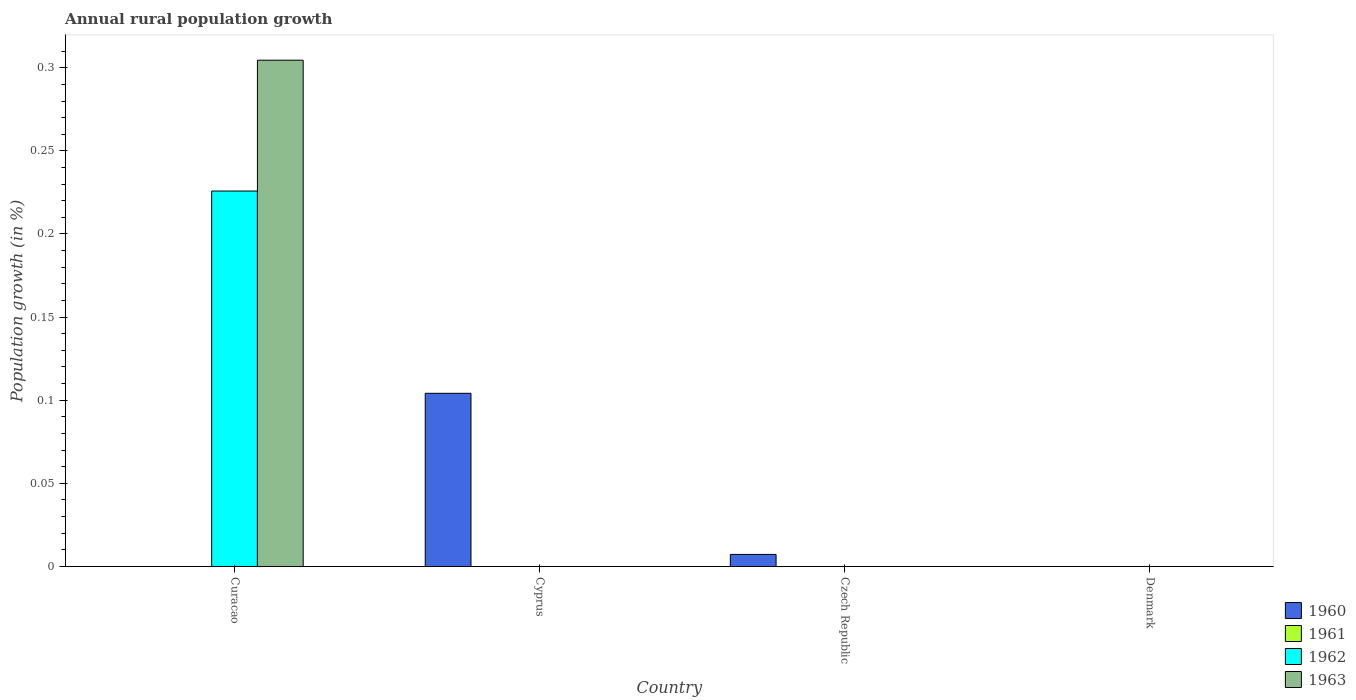How many bars are there on the 4th tick from the left?
Offer a terse response. 0. What is the label of the 4th group of bars from the left?
Your response must be concise. Denmark. Across all countries, what is the maximum percentage of rural population growth in 1962?
Keep it short and to the point. 0.23. Across all countries, what is the minimum percentage of rural population growth in 1962?
Your response must be concise. 0. In which country was the percentage of rural population growth in 1962 maximum?
Your response must be concise. Curacao. What is the total percentage of rural population growth in 1961 in the graph?
Provide a succinct answer. 0. What is the difference between the percentage of rural population growth in 1963 in Curacao and the percentage of rural population growth in 1961 in Cyprus?
Provide a succinct answer. 0.3. In how many countries, is the percentage of rural population growth in 1961 greater than 0.04 %?
Offer a terse response. 0. What is the difference between the highest and the lowest percentage of rural population growth in 1962?
Provide a short and direct response. 0.23. Are all the bars in the graph horizontal?
Your answer should be compact. No. What is the difference between two consecutive major ticks on the Y-axis?
Offer a very short reply. 0.05. Are the values on the major ticks of Y-axis written in scientific E-notation?
Your answer should be compact. No. Does the graph contain grids?
Keep it short and to the point. No. What is the title of the graph?
Ensure brevity in your answer.  Annual rural population growth. What is the label or title of the Y-axis?
Offer a very short reply. Population growth (in %). What is the Population growth (in %) in 1961 in Curacao?
Ensure brevity in your answer.  0. What is the Population growth (in %) in 1962 in Curacao?
Ensure brevity in your answer.  0.23. What is the Population growth (in %) in 1963 in Curacao?
Your answer should be compact. 0.3. What is the Population growth (in %) in 1960 in Cyprus?
Offer a terse response. 0.1. What is the Population growth (in %) in 1961 in Cyprus?
Ensure brevity in your answer.  0. What is the Population growth (in %) in 1962 in Cyprus?
Offer a terse response. 0. What is the Population growth (in %) of 1960 in Czech Republic?
Keep it short and to the point. 0.01. What is the Population growth (in %) of 1962 in Denmark?
Keep it short and to the point. 0. Across all countries, what is the maximum Population growth (in %) of 1960?
Keep it short and to the point. 0.1. Across all countries, what is the maximum Population growth (in %) of 1962?
Your response must be concise. 0.23. Across all countries, what is the maximum Population growth (in %) in 1963?
Keep it short and to the point. 0.3. Across all countries, what is the minimum Population growth (in %) of 1960?
Your answer should be very brief. 0. Across all countries, what is the minimum Population growth (in %) in 1963?
Your answer should be very brief. 0. What is the total Population growth (in %) of 1960 in the graph?
Make the answer very short. 0.11. What is the total Population growth (in %) in 1961 in the graph?
Keep it short and to the point. 0. What is the total Population growth (in %) of 1962 in the graph?
Make the answer very short. 0.23. What is the total Population growth (in %) in 1963 in the graph?
Give a very brief answer. 0.3. What is the difference between the Population growth (in %) in 1960 in Cyprus and that in Czech Republic?
Give a very brief answer. 0.1. What is the average Population growth (in %) in 1960 per country?
Keep it short and to the point. 0.03. What is the average Population growth (in %) of 1962 per country?
Your response must be concise. 0.06. What is the average Population growth (in %) of 1963 per country?
Your response must be concise. 0.08. What is the difference between the Population growth (in %) in 1962 and Population growth (in %) in 1963 in Curacao?
Keep it short and to the point. -0.08. What is the ratio of the Population growth (in %) of 1960 in Cyprus to that in Czech Republic?
Your answer should be compact. 14.35. What is the difference between the highest and the lowest Population growth (in %) in 1960?
Ensure brevity in your answer.  0.1. What is the difference between the highest and the lowest Population growth (in %) in 1962?
Give a very brief answer. 0.23. What is the difference between the highest and the lowest Population growth (in %) in 1963?
Keep it short and to the point. 0.3. 